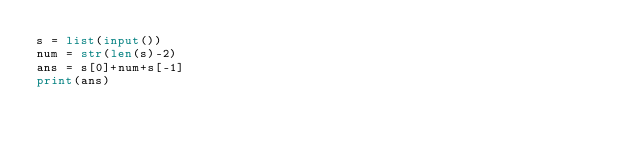<code> <loc_0><loc_0><loc_500><loc_500><_Python_>s = list(input())
num = str(len(s)-2)
ans = s[0]+num+s[-1]
print(ans)</code> 